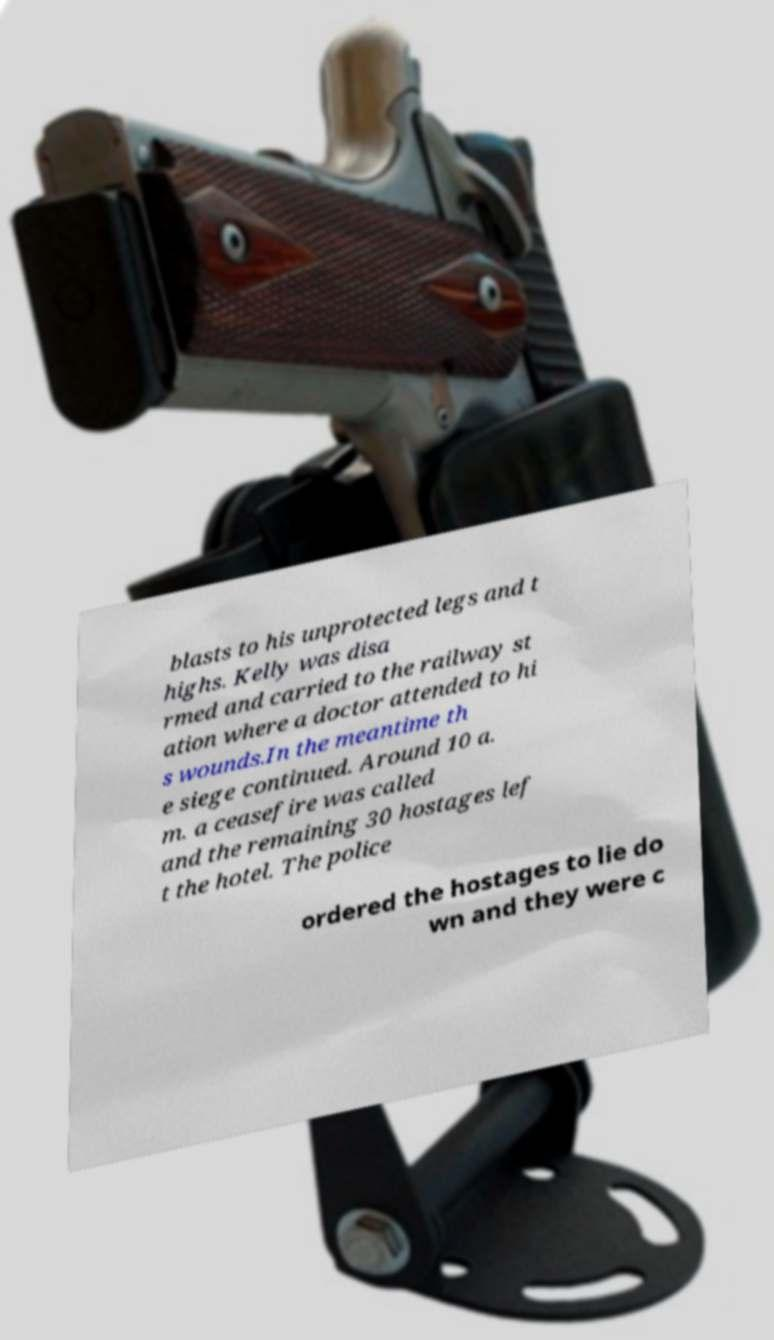There's text embedded in this image that I need extracted. Can you transcribe it verbatim? blasts to his unprotected legs and t highs. Kelly was disa rmed and carried to the railway st ation where a doctor attended to hi s wounds.In the meantime th e siege continued. Around 10 a. m. a ceasefire was called and the remaining 30 hostages lef t the hotel. The police ordered the hostages to lie do wn and they were c 